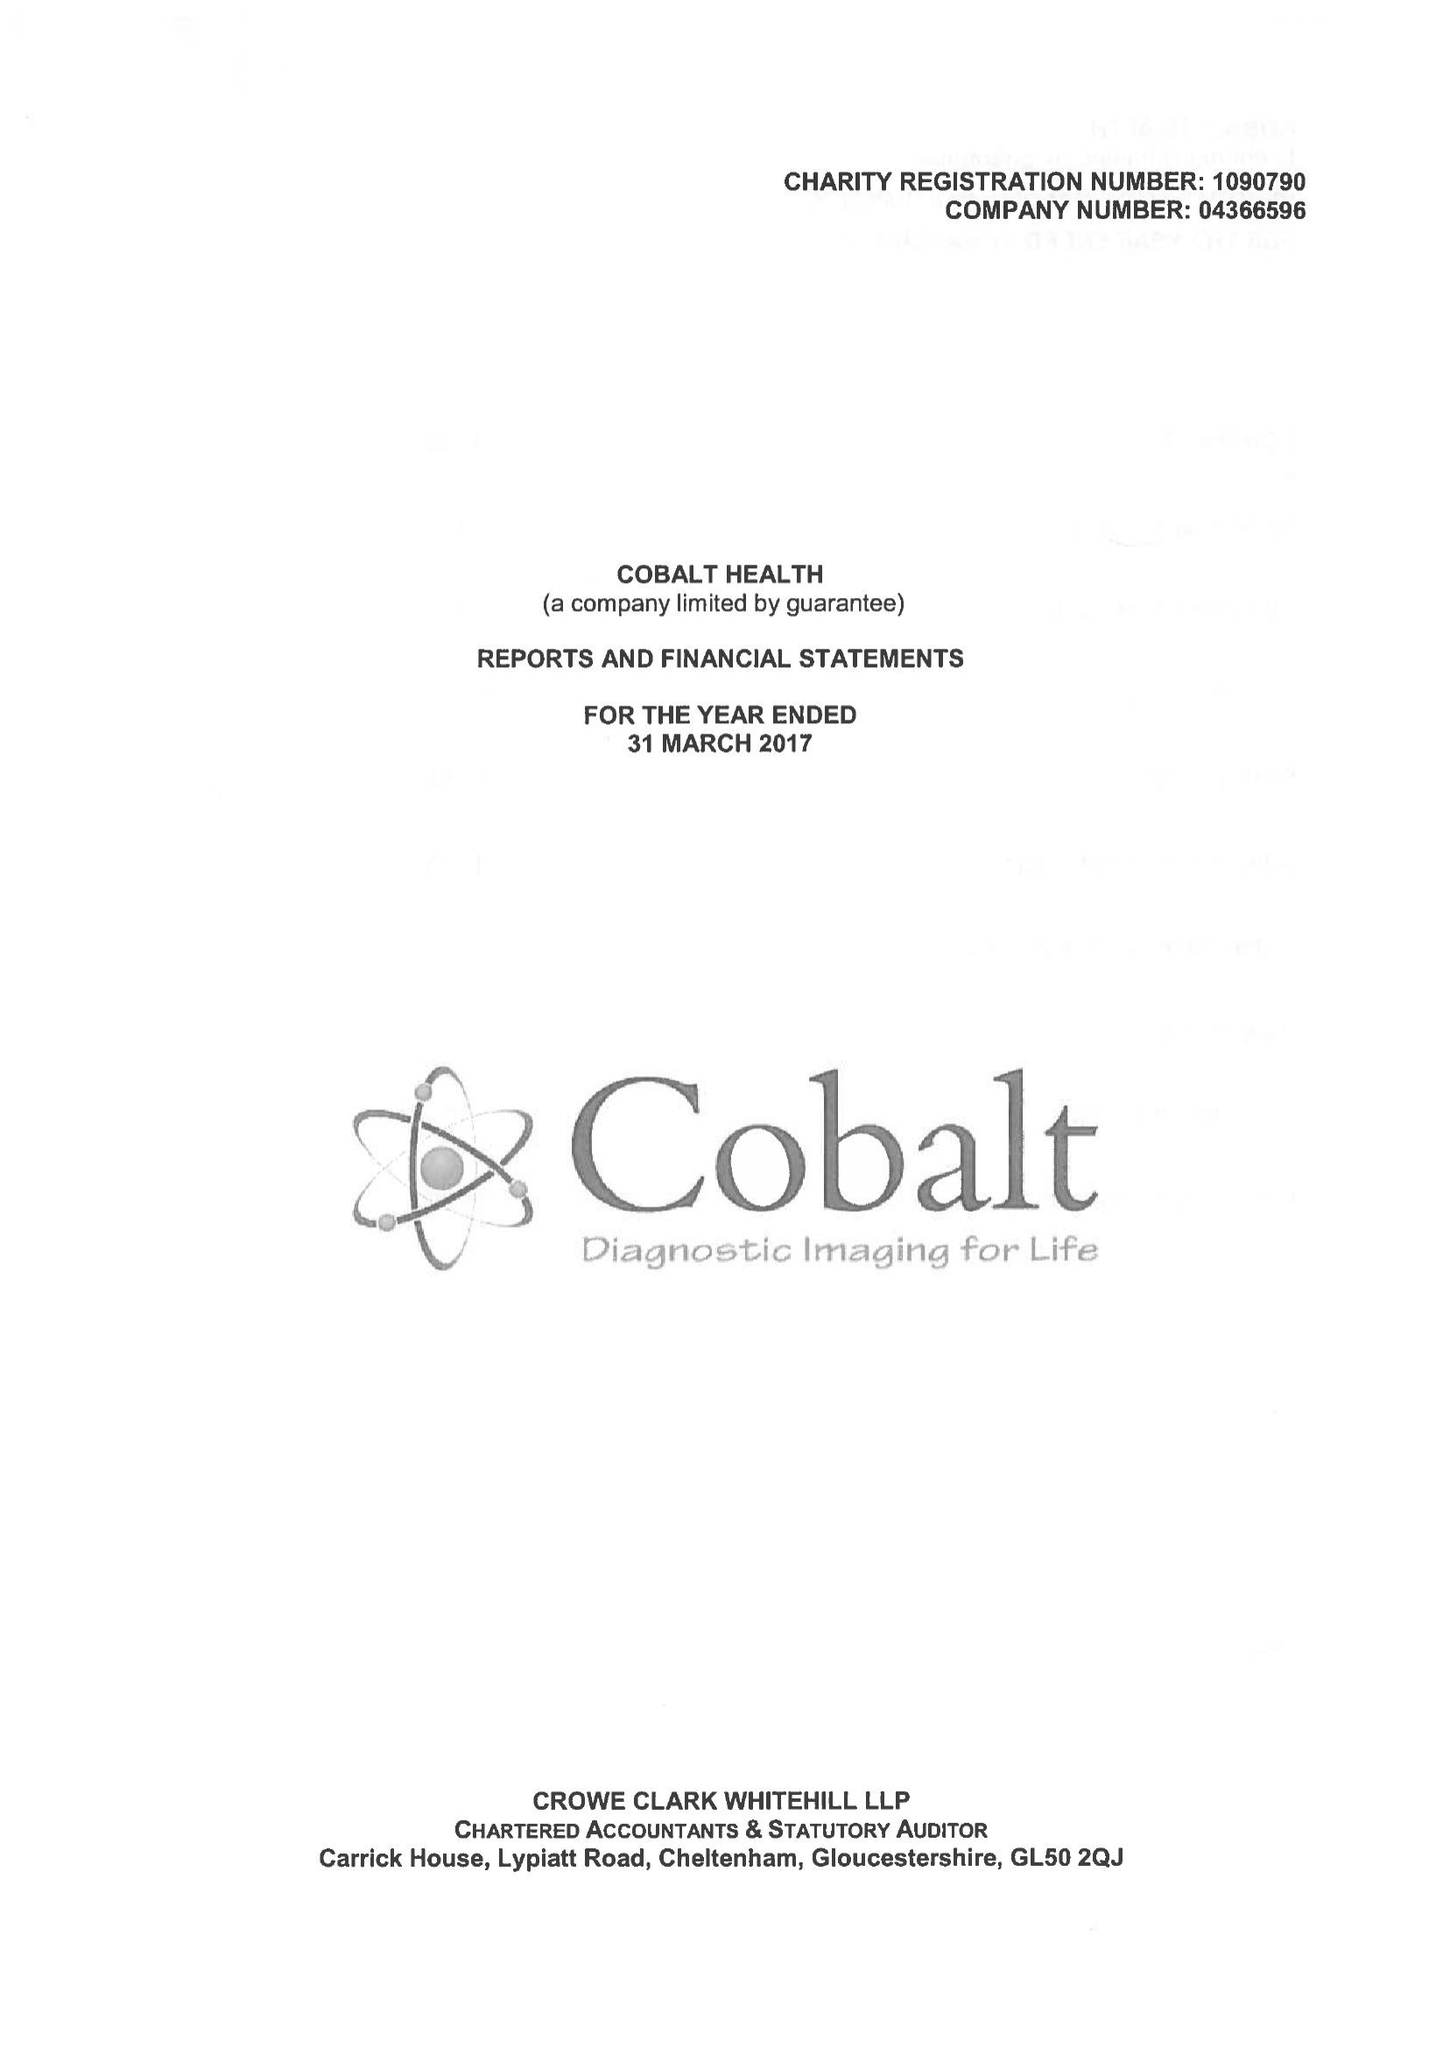What is the value for the address__postcode?
Answer the question using a single word or phrase. GL53 7AS 